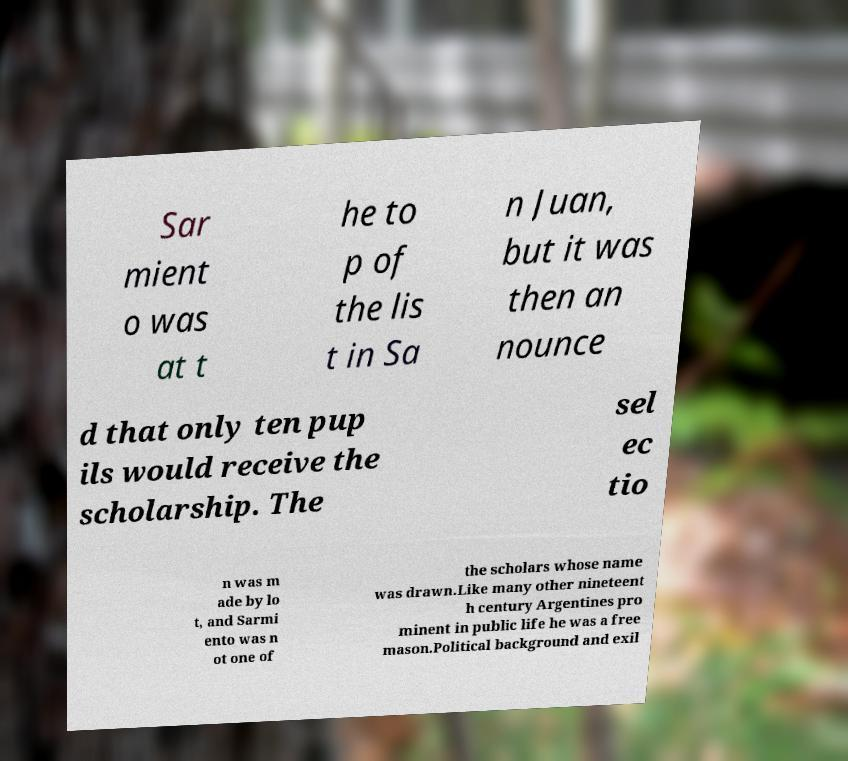I need the written content from this picture converted into text. Can you do that? Sar mient o was at t he to p of the lis t in Sa n Juan, but it was then an nounce d that only ten pup ils would receive the scholarship. The sel ec tio n was m ade by lo t, and Sarmi ento was n ot one of the scholars whose name was drawn.Like many other nineteent h century Argentines pro minent in public life he was a free mason.Political background and exil 